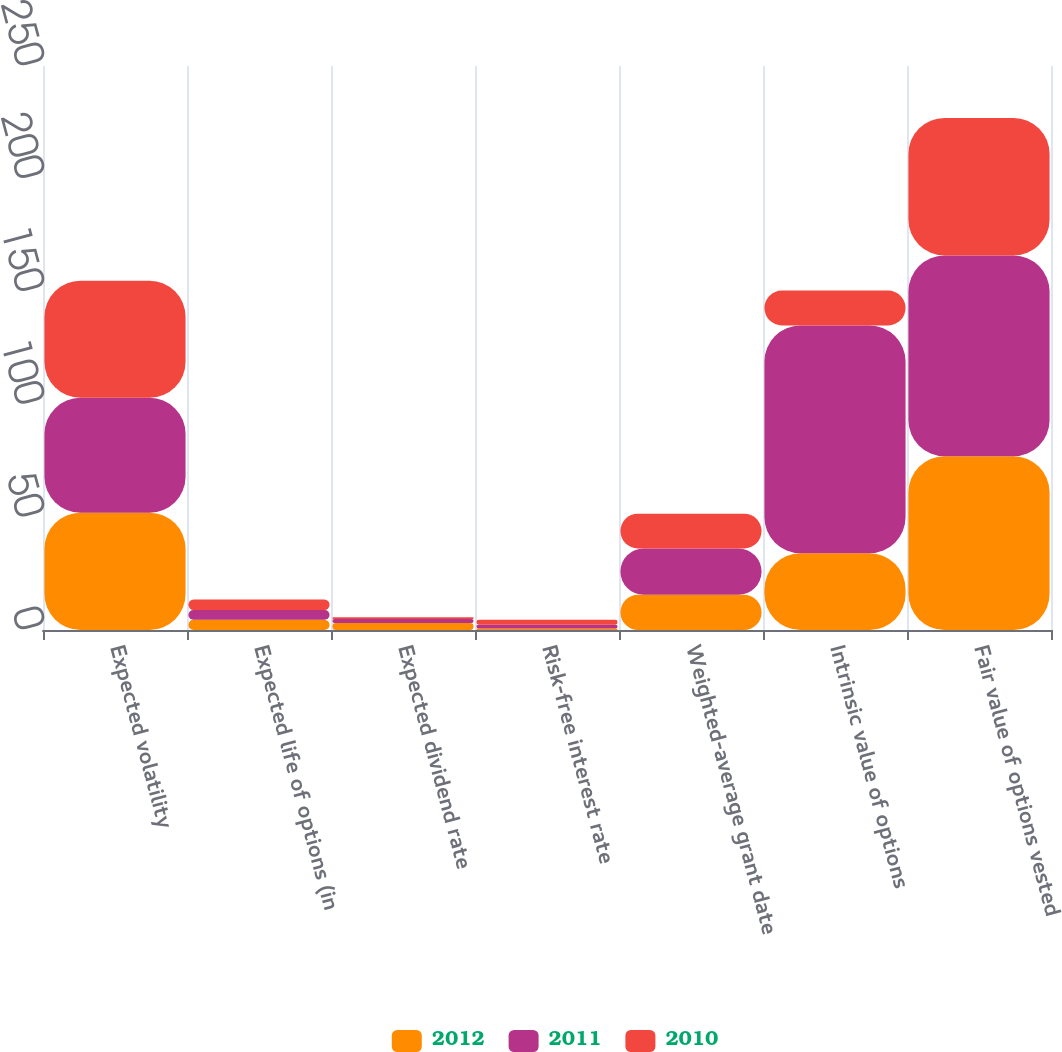Convert chart. <chart><loc_0><loc_0><loc_500><loc_500><stacked_bar_chart><ecel><fcel>Expected volatility<fcel>Expected life of options (in<fcel>Expected dividend rate<fcel>Risk-free interest rate<fcel>Weighted-average grant date<fcel>Intrinsic value of options<fcel>Fair value of options vested<nl><fcel>2012<fcel>52<fcel>4.54<fcel>3.1<fcel>0.7<fcel>15.6<fcel>34<fcel>77<nl><fcel>2011<fcel>50.9<fcel>4.34<fcel>1.8<fcel>1.6<fcel>20.58<fcel>101<fcel>89<nl><fcel>2010<fcel>51.9<fcel>4.61<fcel>0.8<fcel>2.2<fcel>15.33<fcel>15.465<fcel>61<nl></chart> 